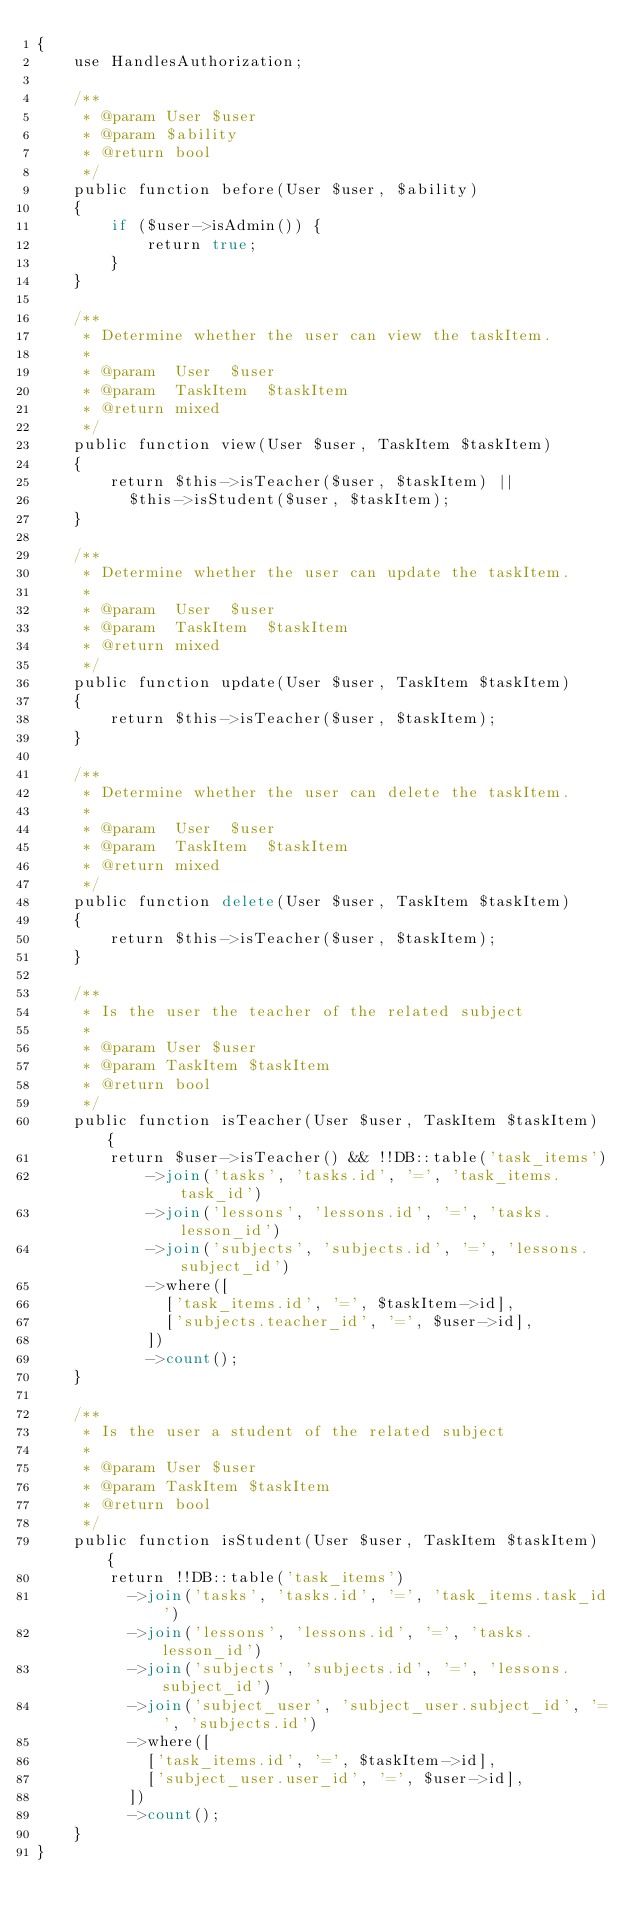Convert code to text. <code><loc_0><loc_0><loc_500><loc_500><_PHP_>{
    use HandlesAuthorization;

    /**
     * @param User $user
     * @param $ability
     * @return bool
     */
    public function before(User $user, $ability)
    {
        if ($user->isAdmin()) {
            return true;
        }
    }

    /**
     * Determine whether the user can view the taskItem.
     *
     * @param  User  $user
     * @param  TaskItem  $taskItem
     * @return mixed
     */
    public function view(User $user, TaskItem $taskItem)
    {
        return $this->isTeacher($user, $taskItem) ||
          $this->isStudent($user, $taskItem);
    }

    /**
     * Determine whether the user can update the taskItem.
     *
     * @param  User  $user
     * @param  TaskItem  $taskItem
     * @return mixed
     */
    public function update(User $user, TaskItem $taskItem)
    {
        return $this->isTeacher($user, $taskItem);
    }

    /**
     * Determine whether the user can delete the taskItem.
     *
     * @param  User  $user
     * @param  TaskItem  $taskItem
     * @return mixed
     */
    public function delete(User $user, TaskItem $taskItem)
    {
        return $this->isTeacher($user, $taskItem);
    }

    /**
     * Is the user the teacher of the related subject
     *
     * @param User $user
     * @param TaskItem $taskItem
     * @return bool
     */
    public function isTeacher(User $user, TaskItem $taskItem) {
        return $user->isTeacher() && !!DB::table('task_items')
            ->join('tasks', 'tasks.id', '=', 'task_items.task_id')
            ->join('lessons', 'lessons.id', '=', 'tasks.lesson_id')
            ->join('subjects', 'subjects.id', '=', 'lessons.subject_id')
            ->where([
              ['task_items.id', '=', $taskItem->id],
              ['subjects.teacher_id', '=', $user->id],
            ])
            ->count();
    }

    /**
     * Is the user a student of the related subject
     *
     * @param User $user
     * @param TaskItem $taskItem
     * @return bool
     */
    public function isStudent(User $user, TaskItem $taskItem) {
        return !!DB::table('task_items')
          ->join('tasks', 'tasks.id', '=', 'task_items.task_id')
          ->join('lessons', 'lessons.id', '=', 'tasks.lesson_id')
          ->join('subjects', 'subjects.id', '=', 'lessons.subject_id')
          ->join('subject_user', 'subject_user.subject_id', '=', 'subjects.id')
          ->where([
            ['task_items.id', '=', $taskItem->id],
            ['subject_user.user_id', '=', $user->id],
          ])
          ->count();
    }
}
</code> 